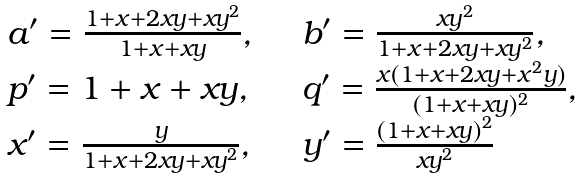Convert formula to latex. <formula><loc_0><loc_0><loc_500><loc_500>\begin{array} { l l } a ^ { \prime } = \frac { 1 + x + 2 x y + x y ^ { 2 } } { 1 + x + x y } , & \quad b ^ { \prime } = \frac { x y ^ { 2 } } { 1 + x + 2 x y + x y ^ { 2 } } , \\ p ^ { \prime } = 1 + x + x y , & \quad q ^ { \prime } = \frac { x ( 1 + x + 2 x y + x ^ { 2 } y ) } { ( 1 + x + x y ) ^ { 2 } } , \\ x ^ { \prime } = \frac { y } { 1 + x + 2 x y + x y ^ { 2 } } , & \quad y ^ { \prime } = \frac { ( 1 + x + x y ) ^ { 2 } } { x y ^ { 2 } } \end{array}</formula> 